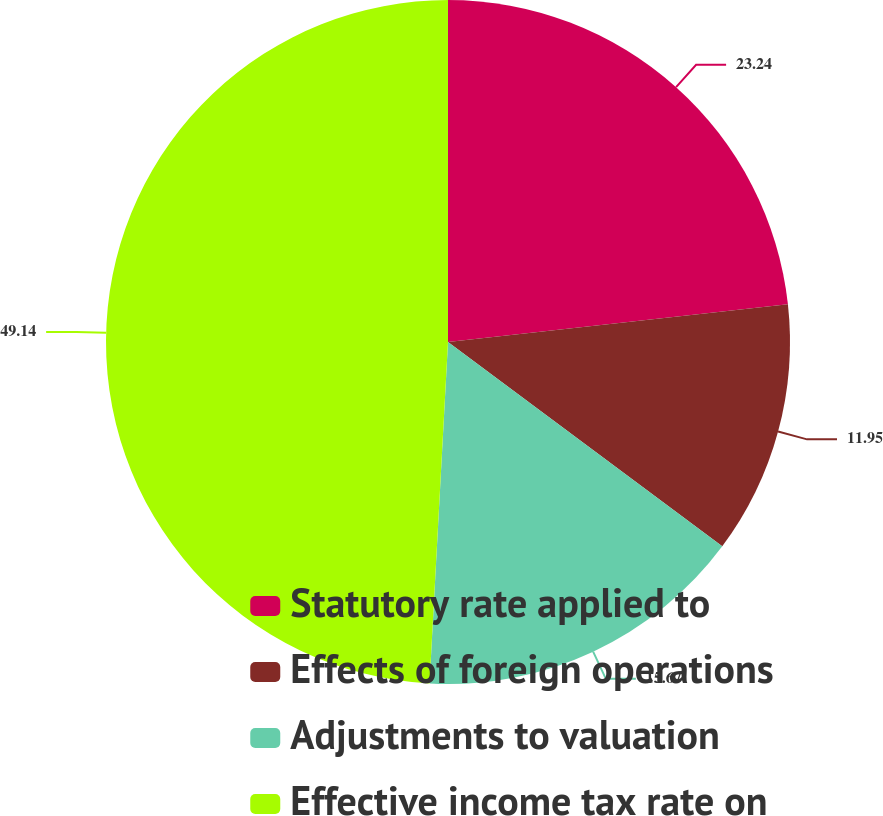Convert chart. <chart><loc_0><loc_0><loc_500><loc_500><pie_chart><fcel>Statutory rate applied to<fcel>Effects of foreign operations<fcel>Adjustments to valuation<fcel>Effective income tax rate on<nl><fcel>23.24%<fcel>11.95%<fcel>15.67%<fcel>49.14%<nl></chart> 